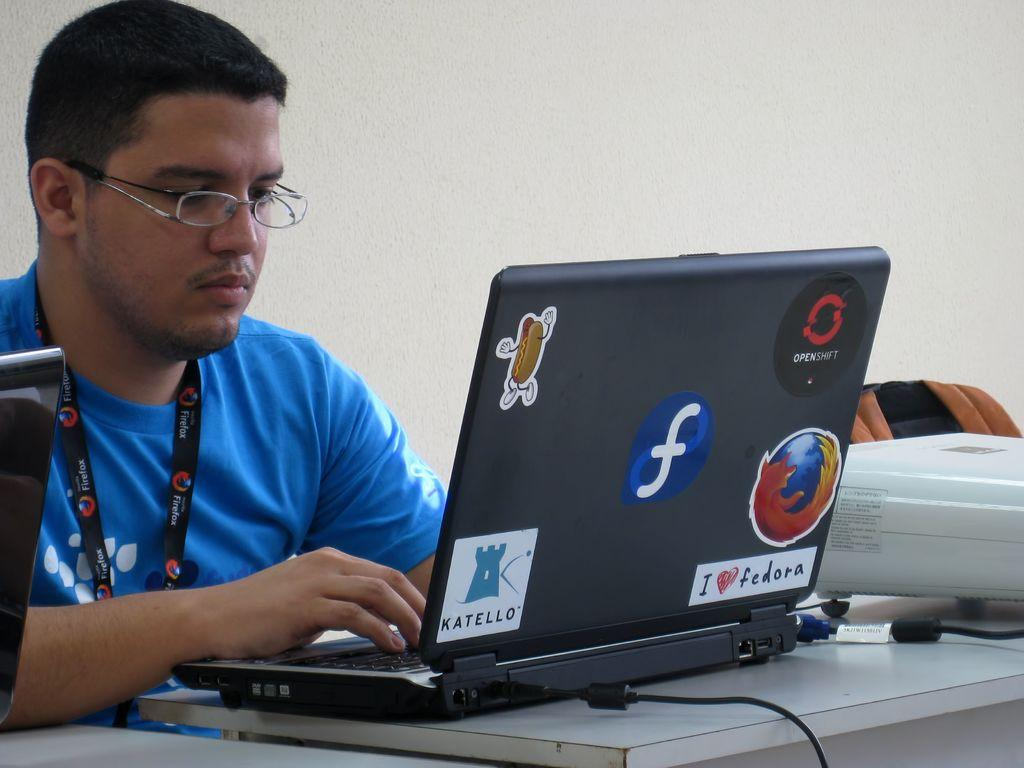<image>
Create a compact narrative representing the image presented. A man is using a laptop with a sticker that says Katello. 